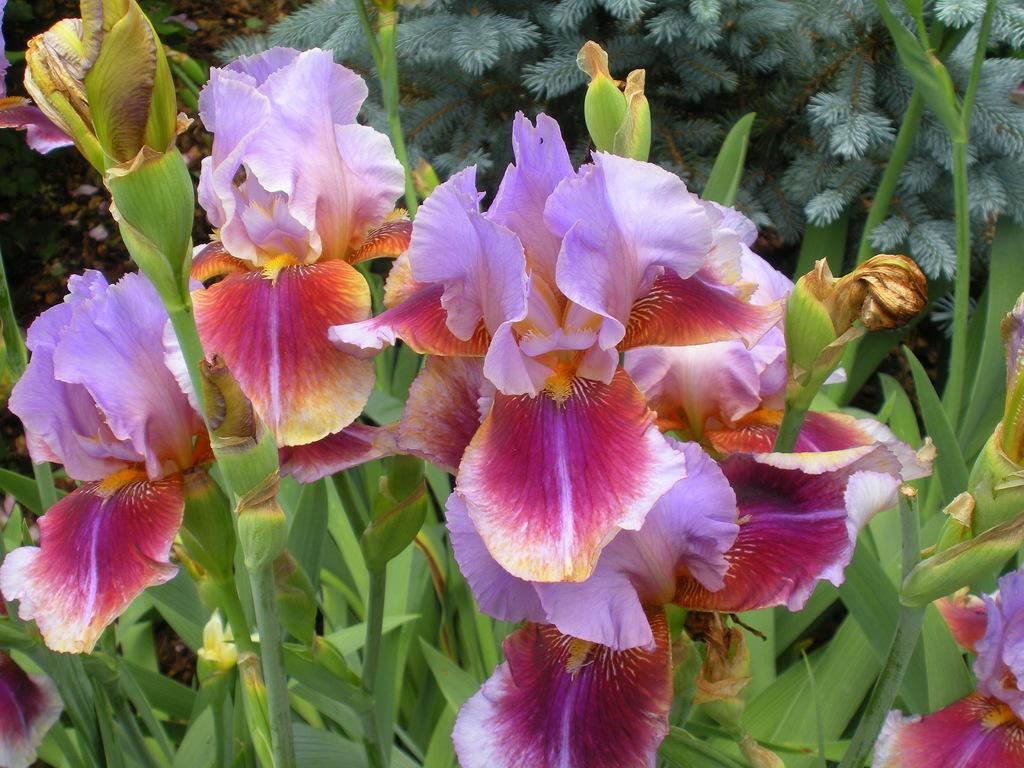What colors are the flowers in the image? The flowers in the image are in pink and purple colors. What other type of plant can be seen in the image? There are plants in green color in the image. What type of ornament is hanging from the flowers in the image? There is no ornament hanging from the flowers in the image; it only shows flowers and plants. 